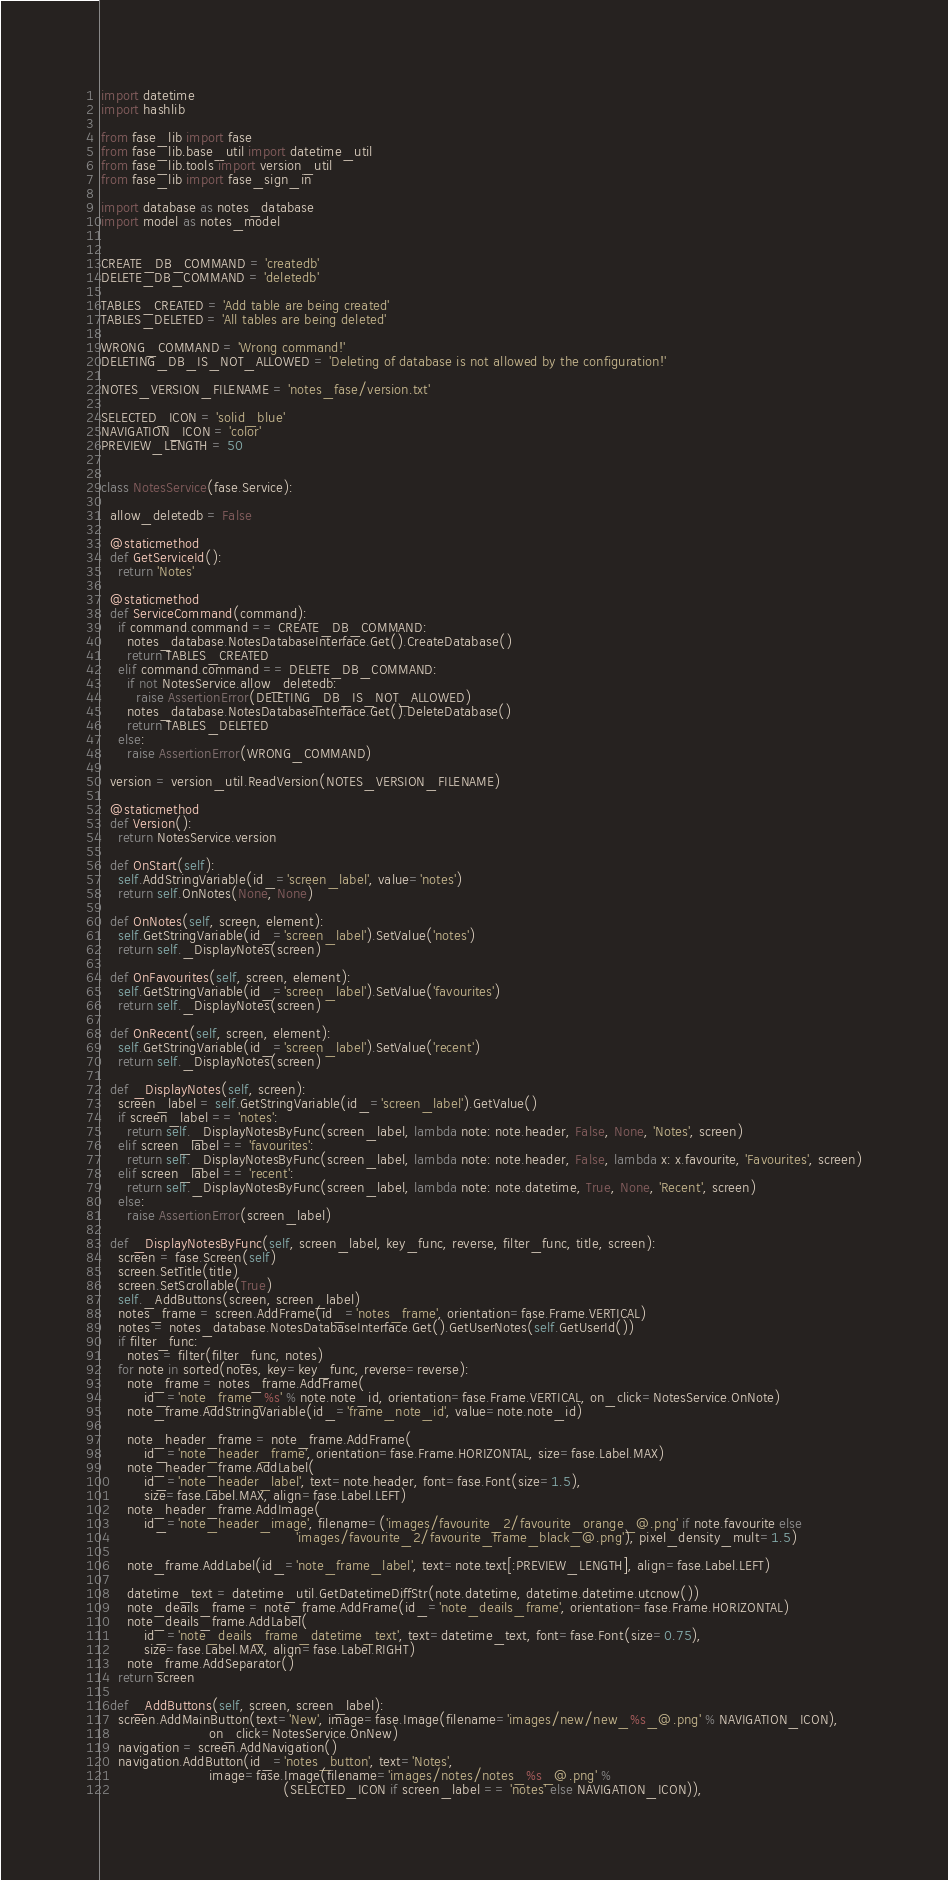Convert code to text. <code><loc_0><loc_0><loc_500><loc_500><_Python_>import datetime
import hashlib

from fase_lib import fase
from fase_lib.base_util import datetime_util
from fase_lib.tools import version_util
from fase_lib import fase_sign_in

import database as notes_database
import model as notes_model


CREATE_DB_COMMAND = 'createdb'
DELETE_DB_COMMAND = 'deletedb'

TABLES_CREATED = 'Add table are being created'
TABLES_DELETED = 'All tables are being deleted'

WRONG_COMMAND = 'Wrong command!'
DELETING_DB_IS_NOT_ALLOWED = 'Deleting of database is not allowed by the configuration!'

NOTES_VERSION_FILENAME = 'notes_fase/version.txt'

SELECTED_ICON = 'solid_blue'
NAVIGATION_ICON = 'color'
PREVIEW_LENGTH = 50


class NotesService(fase.Service):

  allow_deletedb = False

  @staticmethod
  def GetServiceId():
    return 'Notes'

  @staticmethod
  def ServiceCommand(command):
    if command.command == CREATE_DB_COMMAND:
      notes_database.NotesDatabaseInterface.Get().CreateDatabase()
      return TABLES_CREATED
    elif command.command == DELETE_DB_COMMAND:
      if not NotesService.allow_deletedb:
        raise AssertionError(DELETING_DB_IS_NOT_ALLOWED)
      notes_database.NotesDatabaseInterface.Get().DeleteDatabase()
      return TABLES_DELETED
    else:
      raise AssertionError(WRONG_COMMAND)

  version = version_util.ReadVersion(NOTES_VERSION_FILENAME)

  @staticmethod
  def Version():
    return NotesService.version

  def OnStart(self):
    self.AddStringVariable(id_='screen_label', value='notes')
    return self.OnNotes(None, None)

  def OnNotes(self, screen, element):
    self.GetStringVariable(id_='screen_label').SetValue('notes')
    return self._DisplayNotes(screen)

  def OnFavourites(self, screen, element):
    self.GetStringVariable(id_='screen_label').SetValue('favourites')
    return self._DisplayNotes(screen)

  def OnRecent(self, screen, element):
    self.GetStringVariable(id_='screen_label').SetValue('recent')
    return self._DisplayNotes(screen)
  
  def _DisplayNotes(self, screen):
    screen_label = self.GetStringVariable(id_='screen_label').GetValue()
    if screen_label == 'notes':
      return self._DisplayNotesByFunc(screen_label, lambda note: note.header, False, None, 'Notes', screen)
    elif screen_label == 'favourites':
      return self._DisplayNotesByFunc(screen_label, lambda note: note.header, False, lambda x: x.favourite, 'Favourites', screen)
    elif screen_label == 'recent':
      return self._DisplayNotesByFunc(screen_label, lambda note: note.datetime, True, None, 'Recent', screen)
    else:
      raise AssertionError(screen_label)

  def _DisplayNotesByFunc(self, screen_label, key_func, reverse, filter_func, title, screen):
    screen = fase.Screen(self)
    screen.SetTitle(title)
    screen.SetScrollable(True)
    self._AddButtons(screen, screen_label)
    notes_frame = screen.AddFrame(id_='notes_frame', orientation=fase.Frame.VERTICAL)
    notes = notes_database.NotesDatabaseInterface.Get().GetUserNotes(self.GetUserId())
    if filter_func:
      notes = filter(filter_func, notes)
    for note in sorted(notes, key=key_func, reverse=reverse):
      note_frame = notes_frame.AddFrame(
          id_='note_frame_%s' % note.note_id, orientation=fase.Frame.VERTICAL, on_click=NotesService.OnNote)
      note_frame.AddStringVariable(id_='frame_note_id', value=note.note_id)

      note_header_frame = note_frame.AddFrame(
          id_='note_header_frame', orientation=fase.Frame.HORIZONTAL, size=fase.Label.MAX)
      note_header_frame.AddLabel(
          id_='note_header_label', text=note.header, font=fase.Font(size=1.5),
          size=fase.Label.MAX, align=fase.Label.LEFT)
      note_header_frame.AddImage(
          id_='note_header_image', filename=('images/favourite_2/favourite_orange_@.png' if note.favourite else
                                             'images/favourite_2/favourite_frame_black_@.png'), pixel_density_mult=1.5)

      note_frame.AddLabel(id_='note_frame_label', text=note.text[:PREVIEW_LENGTH], align=fase.Label.LEFT)

      datetime_text = datetime_util.GetDatetimeDiffStr(note.datetime, datetime.datetime.utcnow())
      note_deails_frame = note_frame.AddFrame(id_='note_deails_frame', orientation=fase.Frame.HORIZONTAL)
      note_deails_frame.AddLabel(
          id_='note_deails_frame_datetime_text', text=datetime_text, font=fase.Font(size=0.75),
          size=fase.Label.MAX, align=fase.Label.RIGHT)
      note_frame.AddSeparator()
    return screen

  def _AddButtons(self, screen, screen_label):
    screen.AddMainButton(text='New', image=fase.Image(filename='images/new/new_%s_@.png' % NAVIGATION_ICON),
                         on_click=NotesService.OnNew)
    navigation = screen.AddNavigation()
    navigation.AddButton(id_='notes_button', text='Notes',
                         image=fase.Image(filename='images/notes/notes_%s_@.png' %
                                          (SELECTED_ICON if screen_label == 'notes' else NAVIGATION_ICON)),</code> 